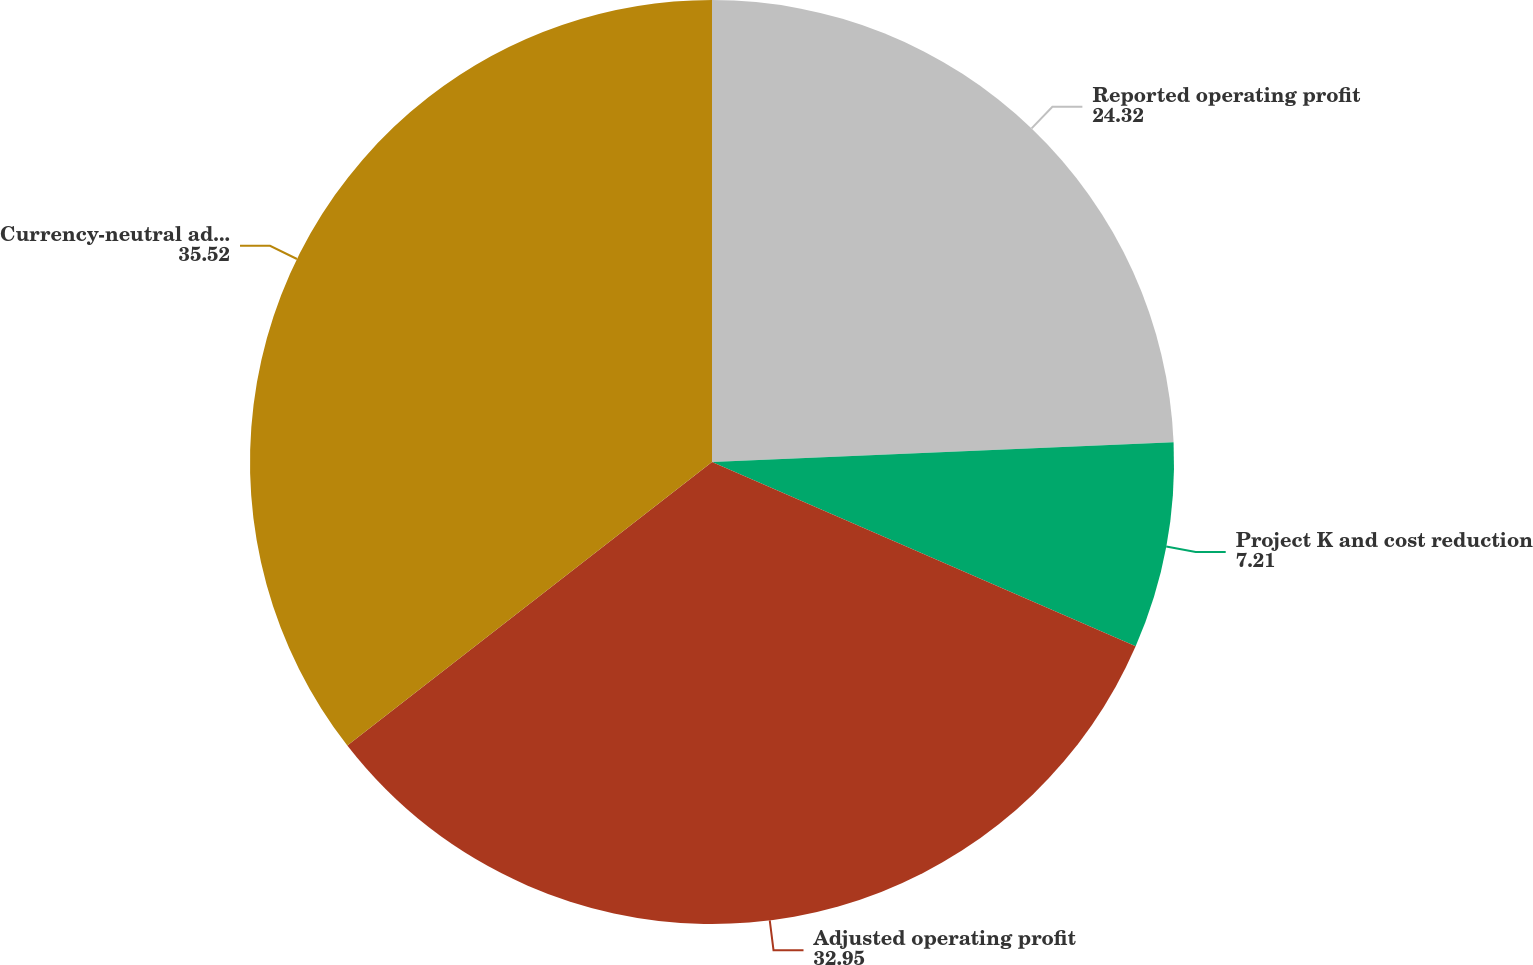Convert chart. <chart><loc_0><loc_0><loc_500><loc_500><pie_chart><fcel>Reported operating profit<fcel>Project K and cost reduction<fcel>Adjusted operating profit<fcel>Currency-neutral adjusted<nl><fcel>24.32%<fcel>7.21%<fcel>32.95%<fcel>35.52%<nl></chart> 